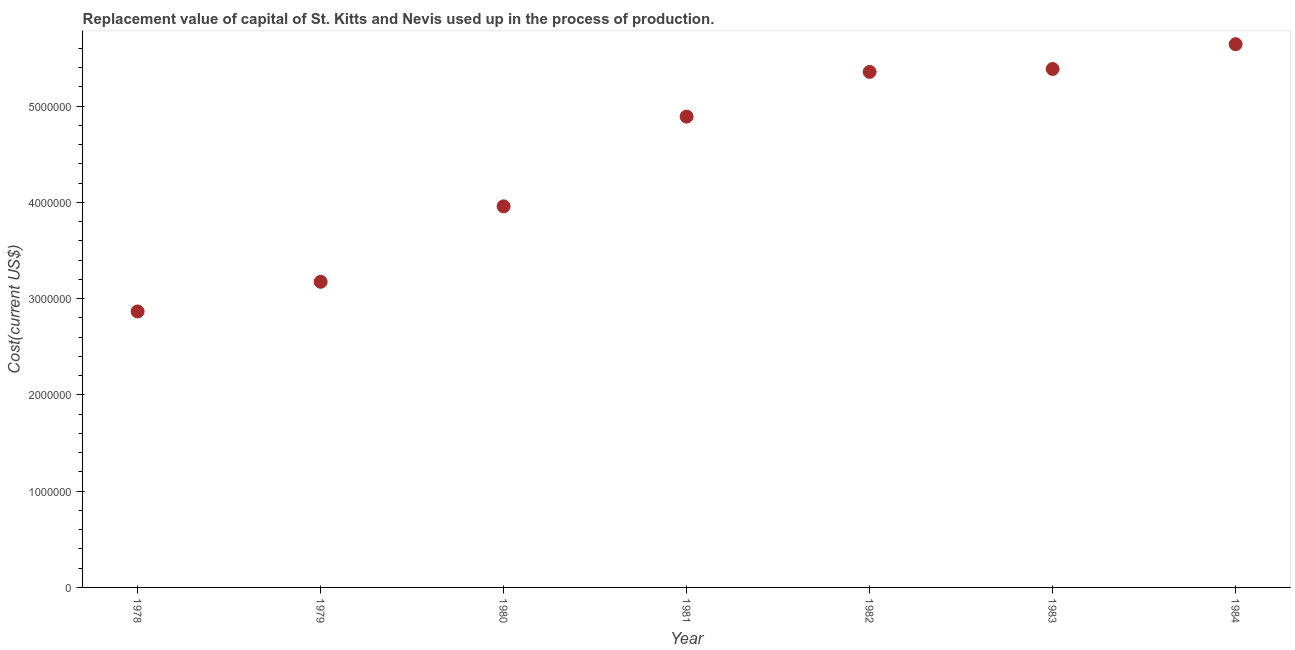What is the consumption of fixed capital in 1978?
Ensure brevity in your answer.  2.87e+06. Across all years, what is the maximum consumption of fixed capital?
Your answer should be very brief. 5.64e+06. Across all years, what is the minimum consumption of fixed capital?
Your response must be concise. 2.87e+06. In which year was the consumption of fixed capital minimum?
Offer a very short reply. 1978. What is the sum of the consumption of fixed capital?
Your answer should be very brief. 3.13e+07. What is the difference between the consumption of fixed capital in 1979 and 1980?
Make the answer very short. -7.84e+05. What is the average consumption of fixed capital per year?
Make the answer very short. 4.47e+06. What is the median consumption of fixed capital?
Make the answer very short. 4.89e+06. What is the ratio of the consumption of fixed capital in 1978 to that in 1981?
Ensure brevity in your answer.  0.59. Is the consumption of fixed capital in 1978 less than that in 1981?
Offer a very short reply. Yes. What is the difference between the highest and the second highest consumption of fixed capital?
Make the answer very short. 2.57e+05. What is the difference between the highest and the lowest consumption of fixed capital?
Your answer should be compact. 2.78e+06. In how many years, is the consumption of fixed capital greater than the average consumption of fixed capital taken over all years?
Give a very brief answer. 4. Does the consumption of fixed capital monotonically increase over the years?
Your answer should be compact. Yes. How many dotlines are there?
Make the answer very short. 1. How many years are there in the graph?
Ensure brevity in your answer.  7. What is the difference between two consecutive major ticks on the Y-axis?
Your answer should be compact. 1.00e+06. Are the values on the major ticks of Y-axis written in scientific E-notation?
Provide a succinct answer. No. Does the graph contain any zero values?
Make the answer very short. No. Does the graph contain grids?
Ensure brevity in your answer.  No. What is the title of the graph?
Give a very brief answer. Replacement value of capital of St. Kitts and Nevis used up in the process of production. What is the label or title of the Y-axis?
Make the answer very short. Cost(current US$). What is the Cost(current US$) in 1978?
Offer a terse response. 2.87e+06. What is the Cost(current US$) in 1979?
Ensure brevity in your answer.  3.17e+06. What is the Cost(current US$) in 1980?
Provide a short and direct response. 3.96e+06. What is the Cost(current US$) in 1981?
Give a very brief answer. 4.89e+06. What is the Cost(current US$) in 1982?
Keep it short and to the point. 5.35e+06. What is the Cost(current US$) in 1983?
Offer a very short reply. 5.39e+06. What is the Cost(current US$) in 1984?
Your answer should be compact. 5.64e+06. What is the difference between the Cost(current US$) in 1978 and 1979?
Your answer should be compact. -3.08e+05. What is the difference between the Cost(current US$) in 1978 and 1980?
Offer a terse response. -1.09e+06. What is the difference between the Cost(current US$) in 1978 and 1981?
Keep it short and to the point. -2.02e+06. What is the difference between the Cost(current US$) in 1978 and 1982?
Offer a very short reply. -2.49e+06. What is the difference between the Cost(current US$) in 1978 and 1983?
Give a very brief answer. -2.52e+06. What is the difference between the Cost(current US$) in 1978 and 1984?
Your response must be concise. -2.78e+06. What is the difference between the Cost(current US$) in 1979 and 1980?
Provide a short and direct response. -7.84e+05. What is the difference between the Cost(current US$) in 1979 and 1981?
Provide a succinct answer. -1.72e+06. What is the difference between the Cost(current US$) in 1979 and 1982?
Offer a terse response. -2.18e+06. What is the difference between the Cost(current US$) in 1979 and 1983?
Ensure brevity in your answer.  -2.21e+06. What is the difference between the Cost(current US$) in 1979 and 1984?
Your answer should be very brief. -2.47e+06. What is the difference between the Cost(current US$) in 1980 and 1981?
Your response must be concise. -9.32e+05. What is the difference between the Cost(current US$) in 1980 and 1982?
Your response must be concise. -1.40e+06. What is the difference between the Cost(current US$) in 1980 and 1983?
Your response must be concise. -1.43e+06. What is the difference between the Cost(current US$) in 1980 and 1984?
Ensure brevity in your answer.  -1.68e+06. What is the difference between the Cost(current US$) in 1981 and 1982?
Keep it short and to the point. -4.64e+05. What is the difference between the Cost(current US$) in 1981 and 1983?
Ensure brevity in your answer.  -4.95e+05. What is the difference between the Cost(current US$) in 1981 and 1984?
Your answer should be compact. -7.52e+05. What is the difference between the Cost(current US$) in 1982 and 1983?
Your answer should be compact. -3.04e+04. What is the difference between the Cost(current US$) in 1982 and 1984?
Offer a very short reply. -2.88e+05. What is the difference between the Cost(current US$) in 1983 and 1984?
Your answer should be very brief. -2.57e+05. What is the ratio of the Cost(current US$) in 1978 to that in 1979?
Keep it short and to the point. 0.9. What is the ratio of the Cost(current US$) in 1978 to that in 1980?
Keep it short and to the point. 0.72. What is the ratio of the Cost(current US$) in 1978 to that in 1981?
Give a very brief answer. 0.59. What is the ratio of the Cost(current US$) in 1978 to that in 1982?
Provide a succinct answer. 0.54. What is the ratio of the Cost(current US$) in 1978 to that in 1983?
Provide a short and direct response. 0.53. What is the ratio of the Cost(current US$) in 1978 to that in 1984?
Keep it short and to the point. 0.51. What is the ratio of the Cost(current US$) in 1979 to that in 1980?
Make the answer very short. 0.8. What is the ratio of the Cost(current US$) in 1979 to that in 1981?
Keep it short and to the point. 0.65. What is the ratio of the Cost(current US$) in 1979 to that in 1982?
Give a very brief answer. 0.59. What is the ratio of the Cost(current US$) in 1979 to that in 1983?
Provide a succinct answer. 0.59. What is the ratio of the Cost(current US$) in 1979 to that in 1984?
Ensure brevity in your answer.  0.56. What is the ratio of the Cost(current US$) in 1980 to that in 1981?
Provide a succinct answer. 0.81. What is the ratio of the Cost(current US$) in 1980 to that in 1982?
Offer a terse response. 0.74. What is the ratio of the Cost(current US$) in 1980 to that in 1983?
Offer a terse response. 0.73. What is the ratio of the Cost(current US$) in 1980 to that in 1984?
Ensure brevity in your answer.  0.7. What is the ratio of the Cost(current US$) in 1981 to that in 1983?
Provide a succinct answer. 0.91. What is the ratio of the Cost(current US$) in 1981 to that in 1984?
Your response must be concise. 0.87. What is the ratio of the Cost(current US$) in 1982 to that in 1984?
Your response must be concise. 0.95. What is the ratio of the Cost(current US$) in 1983 to that in 1984?
Provide a short and direct response. 0.95. 